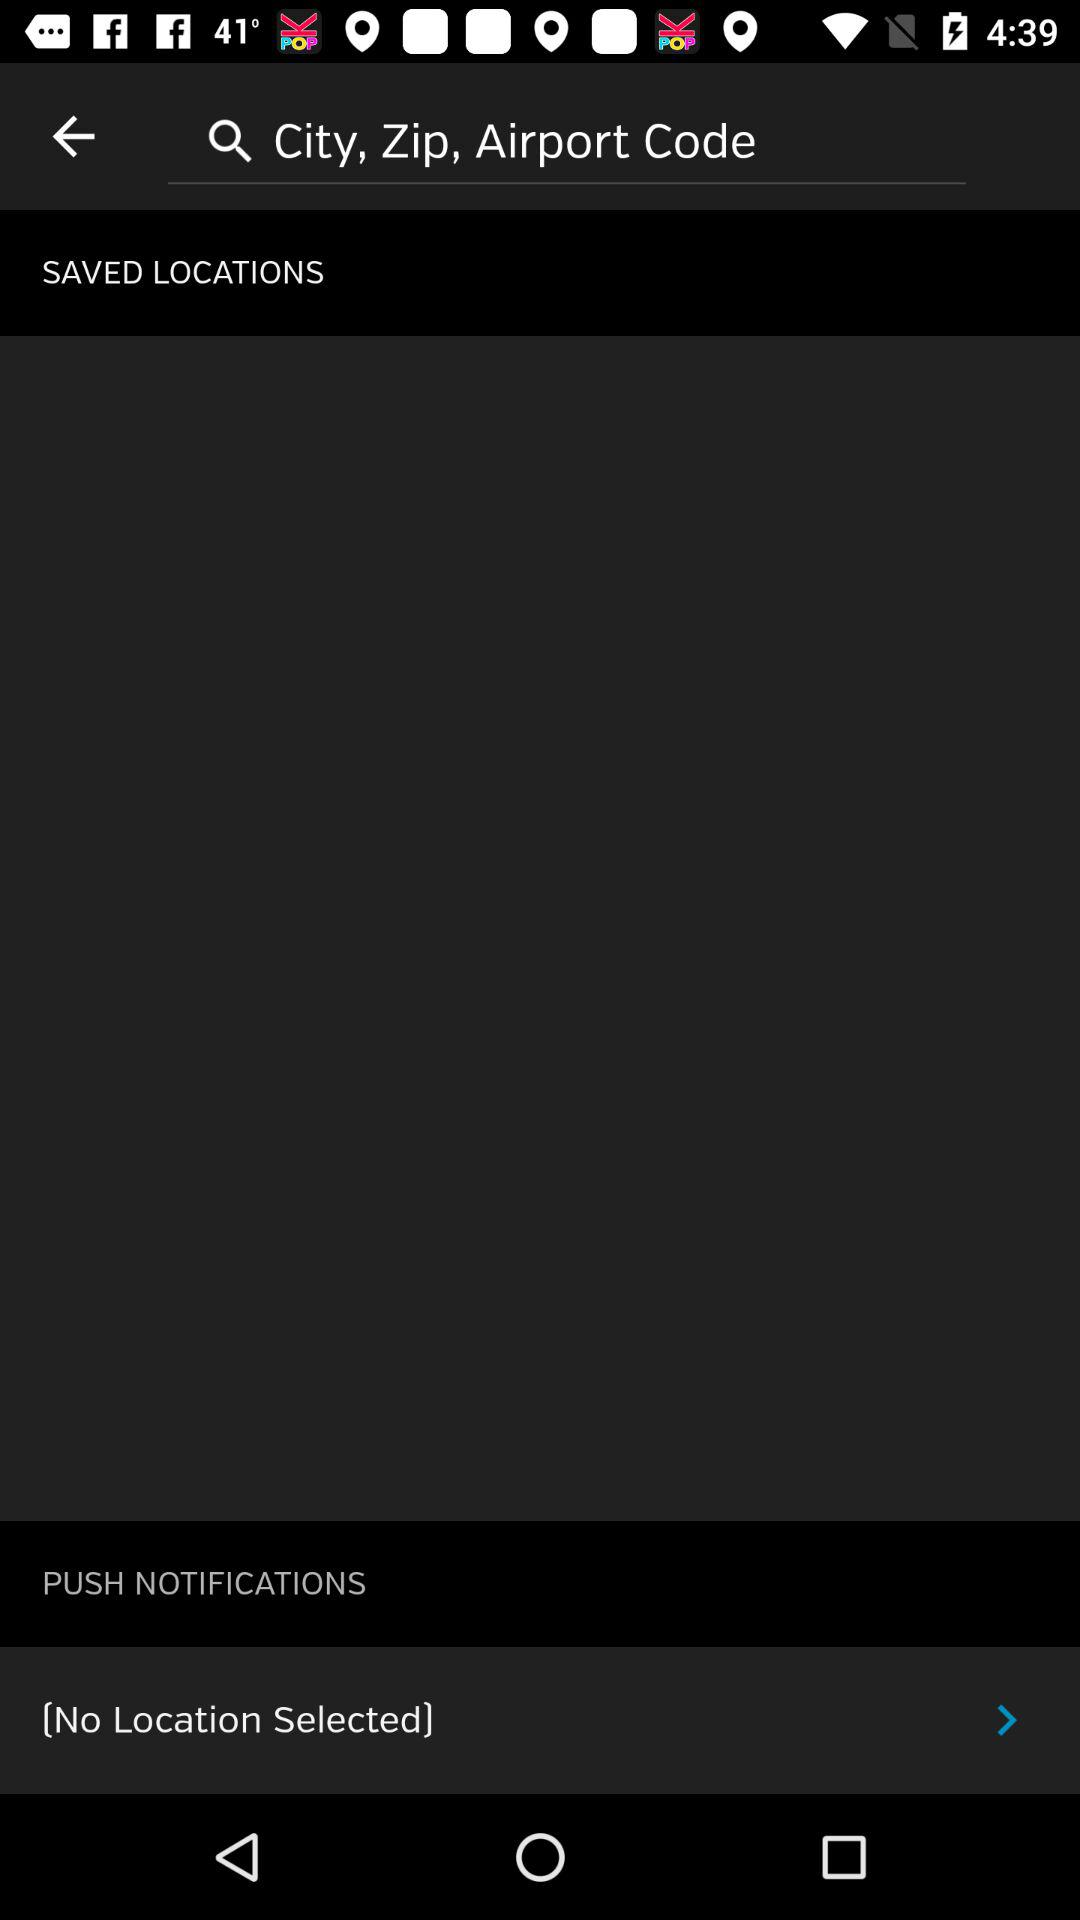Is there any selected location? There is no selected location. 